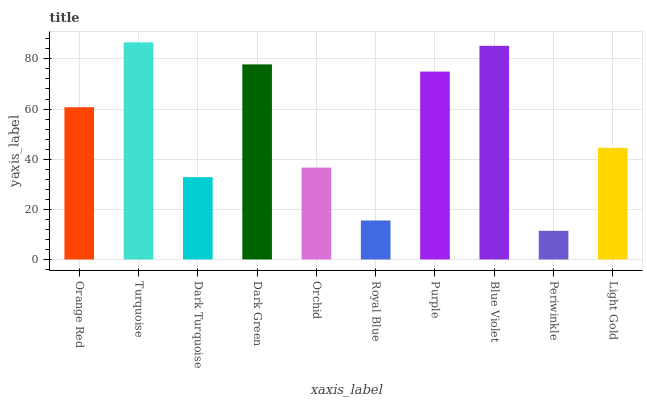Is Periwinkle the minimum?
Answer yes or no. Yes. Is Turquoise the maximum?
Answer yes or no. Yes. Is Dark Turquoise the minimum?
Answer yes or no. No. Is Dark Turquoise the maximum?
Answer yes or no. No. Is Turquoise greater than Dark Turquoise?
Answer yes or no. Yes. Is Dark Turquoise less than Turquoise?
Answer yes or no. Yes. Is Dark Turquoise greater than Turquoise?
Answer yes or no. No. Is Turquoise less than Dark Turquoise?
Answer yes or no. No. Is Orange Red the high median?
Answer yes or no. Yes. Is Light Gold the low median?
Answer yes or no. Yes. Is Dark Turquoise the high median?
Answer yes or no. No. Is Orange Red the low median?
Answer yes or no. No. 